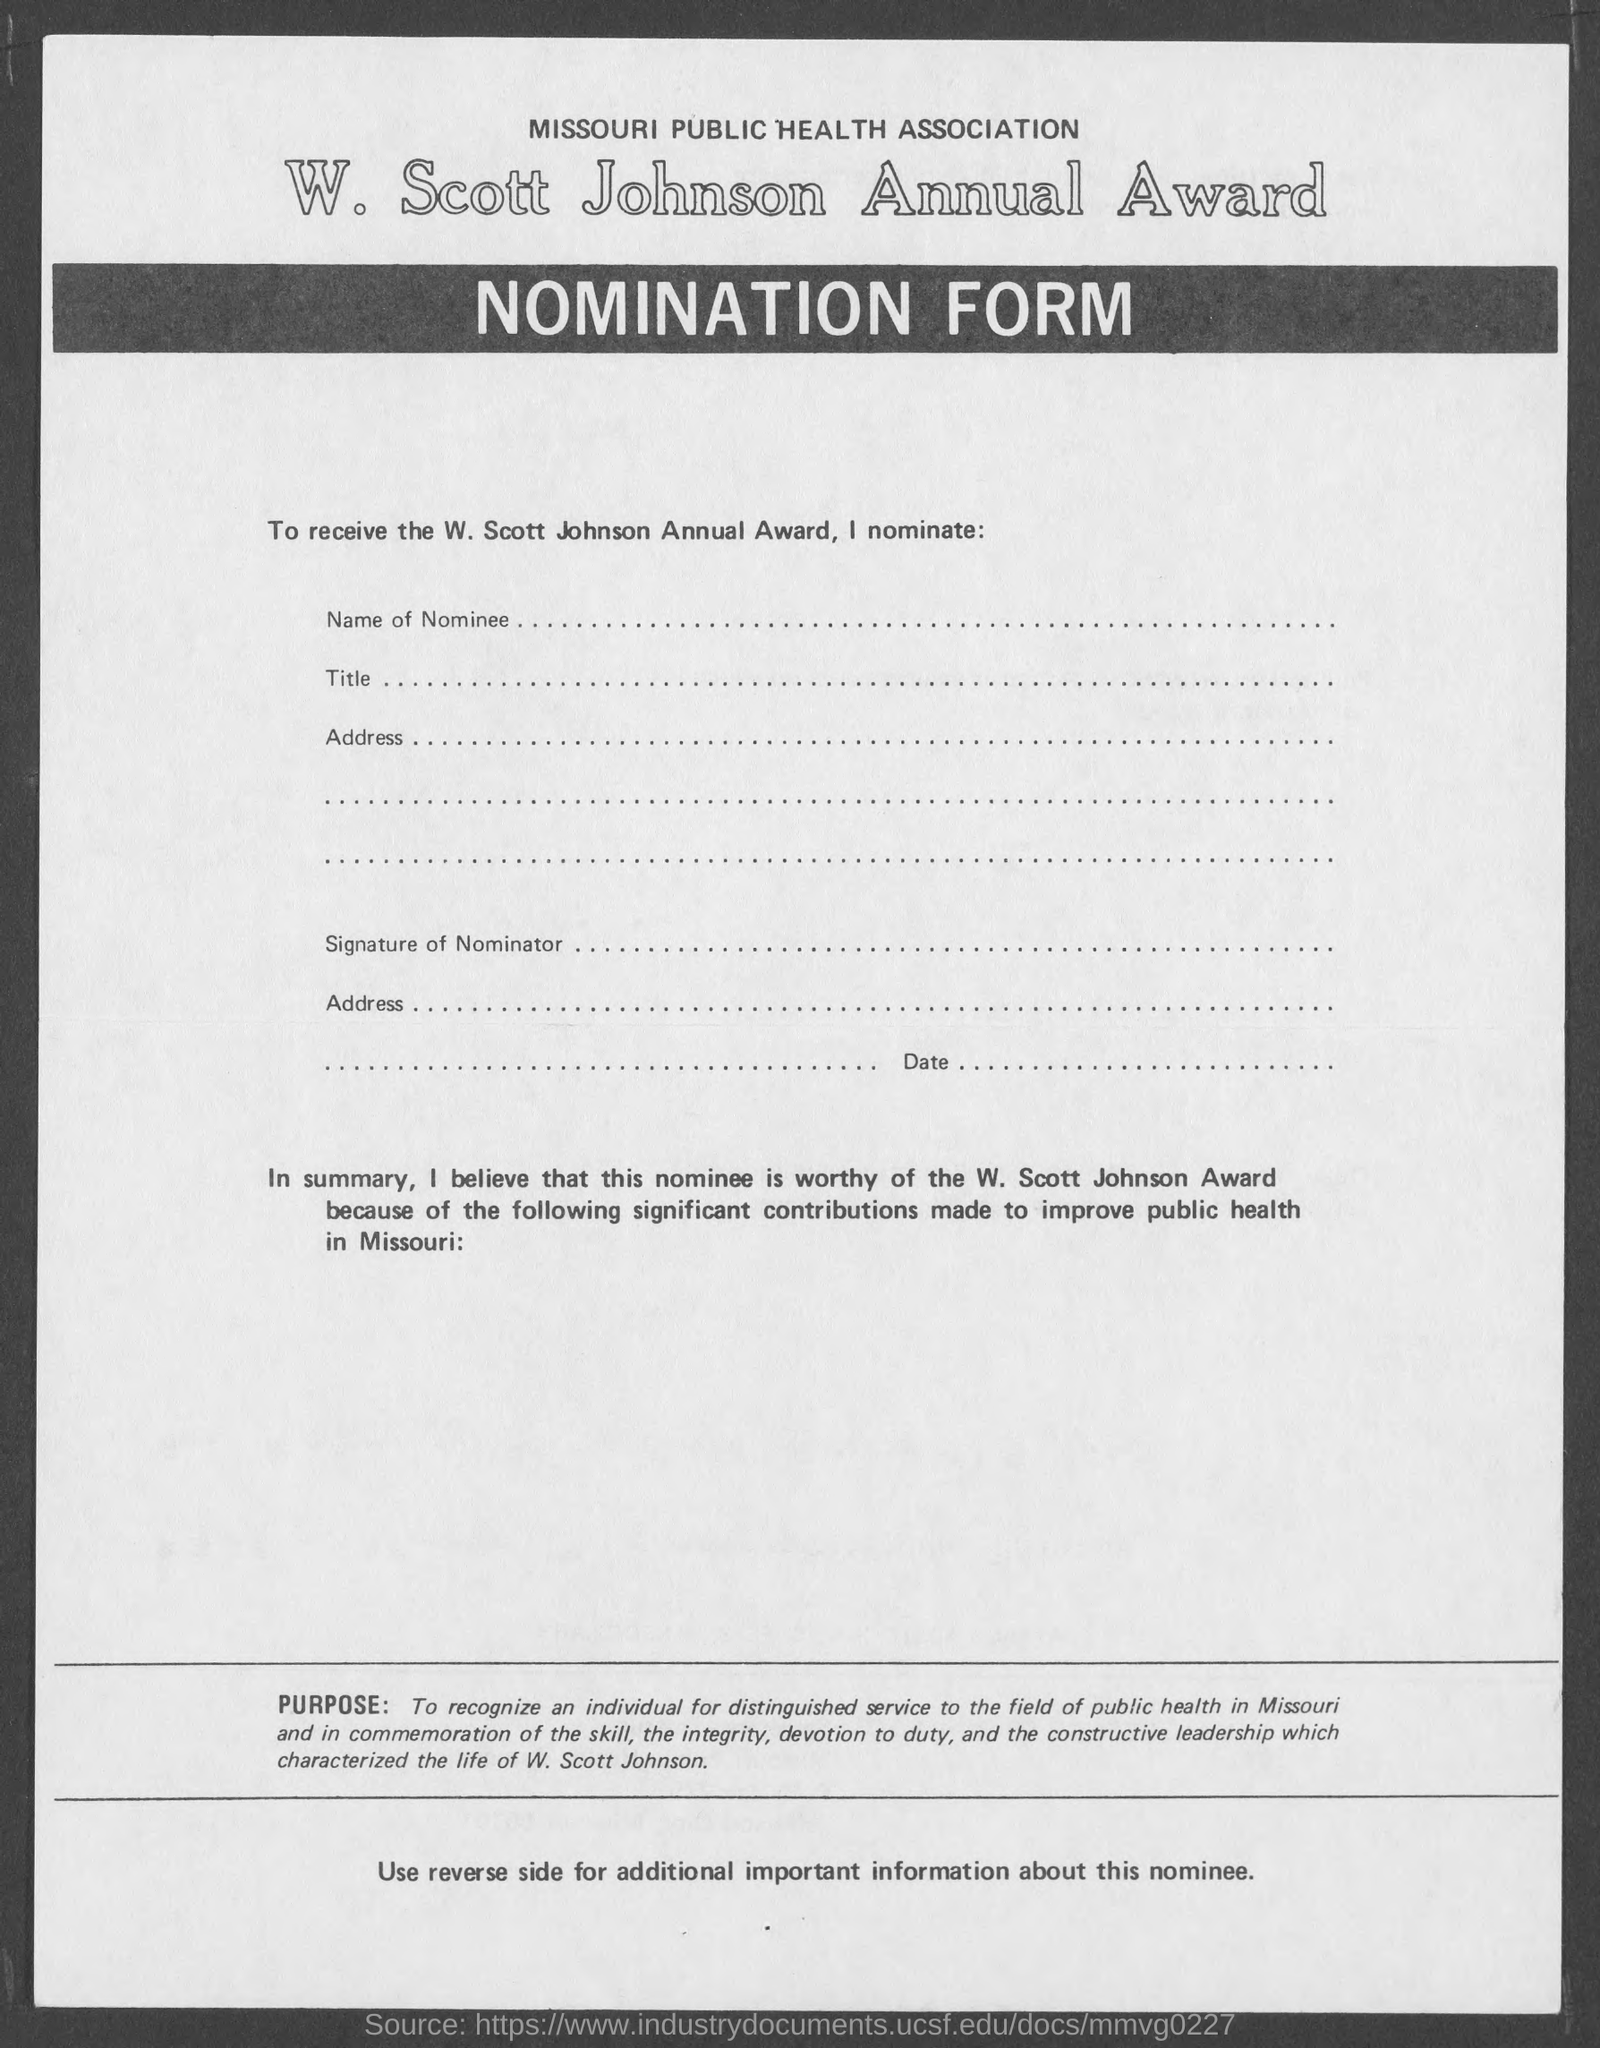Identify some key points in this picture. This form is about nominating someone or something for a particular purpose. 